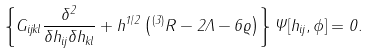Convert formula to latex. <formula><loc_0><loc_0><loc_500><loc_500>\left \{ G _ { i j k l } \frac { \delta ^ { 2 } } { \delta h _ { i j } \delta h _ { k l } } + h ^ { 1 / 2 } \left ( { ^ { ( 3 ) } } R - 2 \Lambda - 6 \varrho \right ) \right \} \Psi [ h _ { i j } , \phi ] = 0 .</formula> 